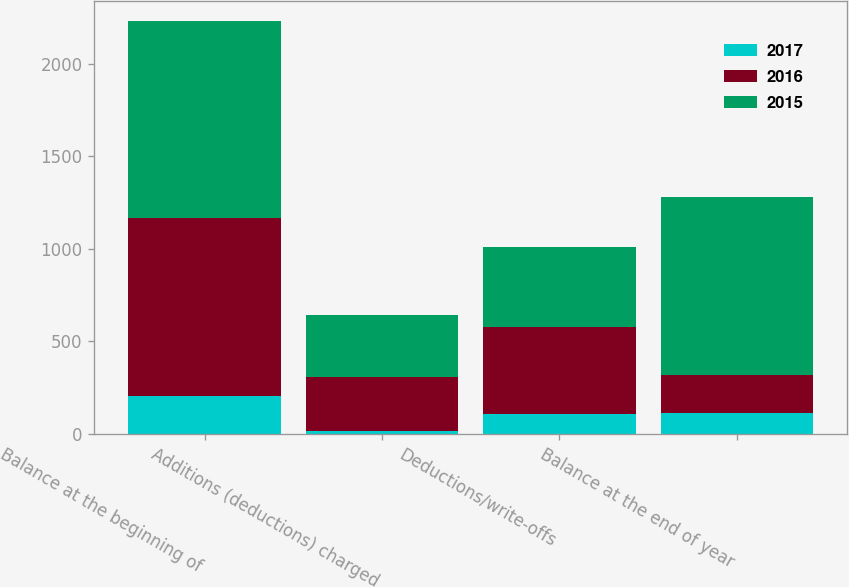<chart> <loc_0><loc_0><loc_500><loc_500><stacked_bar_chart><ecel><fcel>Balance at the beginning of<fcel>Additions (deductions) charged<fcel>Deductions/write-offs<fcel>Balance at the end of year<nl><fcel>2017<fcel>204<fcel>17<fcel>109<fcel>112<nl><fcel>2016<fcel>963<fcel>292<fcel>467<fcel>204<nl><fcel>2015<fcel>1063<fcel>335<fcel>435<fcel>963<nl></chart> 